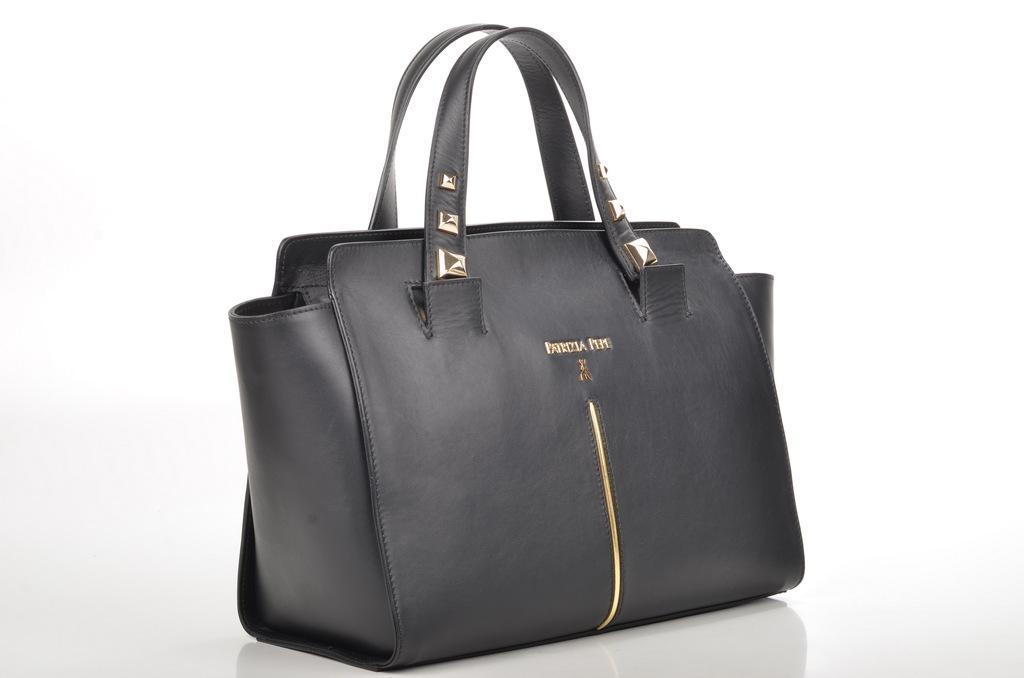How would you summarize this image in a sentence or two? This black handbag is highlighted in this picture. 